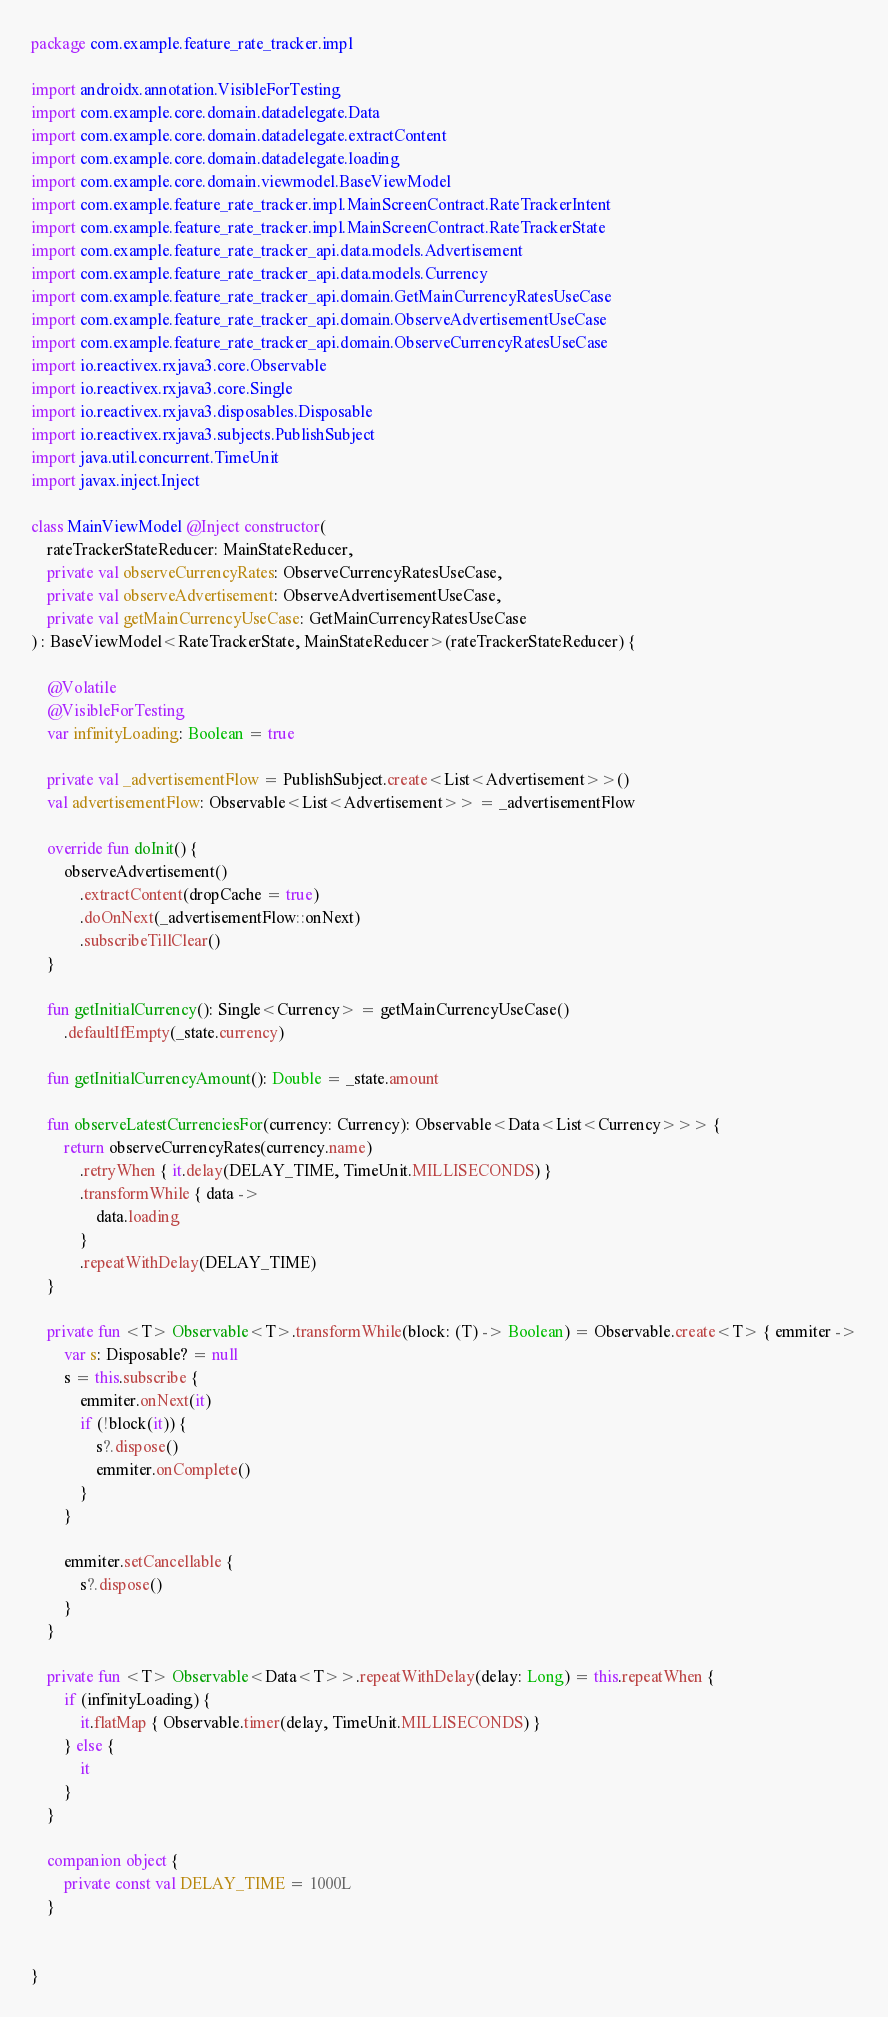<code> <loc_0><loc_0><loc_500><loc_500><_Kotlin_>package com.example.feature_rate_tracker.impl

import androidx.annotation.VisibleForTesting
import com.example.core.domain.datadelegate.Data
import com.example.core.domain.datadelegate.extractContent
import com.example.core.domain.datadelegate.loading
import com.example.core.domain.viewmodel.BaseViewModel
import com.example.feature_rate_tracker.impl.MainScreenContract.RateTrackerIntent
import com.example.feature_rate_tracker.impl.MainScreenContract.RateTrackerState
import com.example.feature_rate_tracker_api.data.models.Advertisement
import com.example.feature_rate_tracker_api.data.models.Currency
import com.example.feature_rate_tracker_api.domain.GetMainCurrencyRatesUseCase
import com.example.feature_rate_tracker_api.domain.ObserveAdvertisementUseCase
import com.example.feature_rate_tracker_api.domain.ObserveCurrencyRatesUseCase
import io.reactivex.rxjava3.core.Observable
import io.reactivex.rxjava3.core.Single
import io.reactivex.rxjava3.disposables.Disposable
import io.reactivex.rxjava3.subjects.PublishSubject
import java.util.concurrent.TimeUnit
import javax.inject.Inject

class MainViewModel @Inject constructor(
    rateTrackerStateReducer: MainStateReducer,
    private val observeCurrencyRates: ObserveCurrencyRatesUseCase,
    private val observeAdvertisement: ObserveAdvertisementUseCase,
    private val getMainCurrencyUseCase: GetMainCurrencyRatesUseCase
) : BaseViewModel<RateTrackerState, MainStateReducer>(rateTrackerStateReducer) {

    @Volatile
    @VisibleForTesting
    var infinityLoading: Boolean = true

    private val _advertisementFlow = PublishSubject.create<List<Advertisement>>()
    val advertisementFlow: Observable<List<Advertisement>> = _advertisementFlow

    override fun doInit() {
        observeAdvertisement()
            .extractContent(dropCache = true)
            .doOnNext(_advertisementFlow::onNext)
            .subscribeTillClear()
    }

    fun getInitialCurrency(): Single<Currency> = getMainCurrencyUseCase()
        .defaultIfEmpty(_state.currency)

    fun getInitialCurrencyAmount(): Double = _state.amount

    fun observeLatestCurrenciesFor(currency: Currency): Observable<Data<List<Currency>>> {
        return observeCurrencyRates(currency.name)
            .retryWhen { it.delay(DELAY_TIME, TimeUnit.MILLISECONDS) }
            .transformWhile { data ->
                data.loading
            }
            .repeatWithDelay(DELAY_TIME)
    }

    private fun <T> Observable<T>.transformWhile(block: (T) -> Boolean) = Observable.create<T> { emmiter ->
        var s: Disposable? = null
        s = this.subscribe {
            emmiter.onNext(it)
            if (!block(it)) {
                s?.dispose()
                emmiter.onComplete()
            }
        }

        emmiter.setCancellable {
            s?.dispose()
        }
    }

    private fun <T> Observable<Data<T>>.repeatWithDelay(delay: Long) = this.repeatWhen {
        if (infinityLoading) {
            it.flatMap { Observable.timer(delay, TimeUnit.MILLISECONDS) }
        } else {
            it
        }
    }

    companion object {
        private const val DELAY_TIME = 1000L
    }


}</code> 